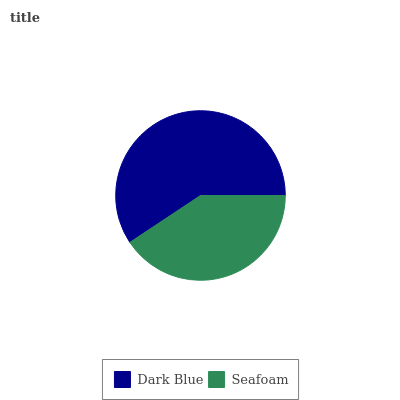Is Seafoam the minimum?
Answer yes or no. Yes. Is Dark Blue the maximum?
Answer yes or no. Yes. Is Seafoam the maximum?
Answer yes or no. No. Is Dark Blue greater than Seafoam?
Answer yes or no. Yes. Is Seafoam less than Dark Blue?
Answer yes or no. Yes. Is Seafoam greater than Dark Blue?
Answer yes or no. No. Is Dark Blue less than Seafoam?
Answer yes or no. No. Is Dark Blue the high median?
Answer yes or no. Yes. Is Seafoam the low median?
Answer yes or no. Yes. Is Seafoam the high median?
Answer yes or no. No. Is Dark Blue the low median?
Answer yes or no. No. 